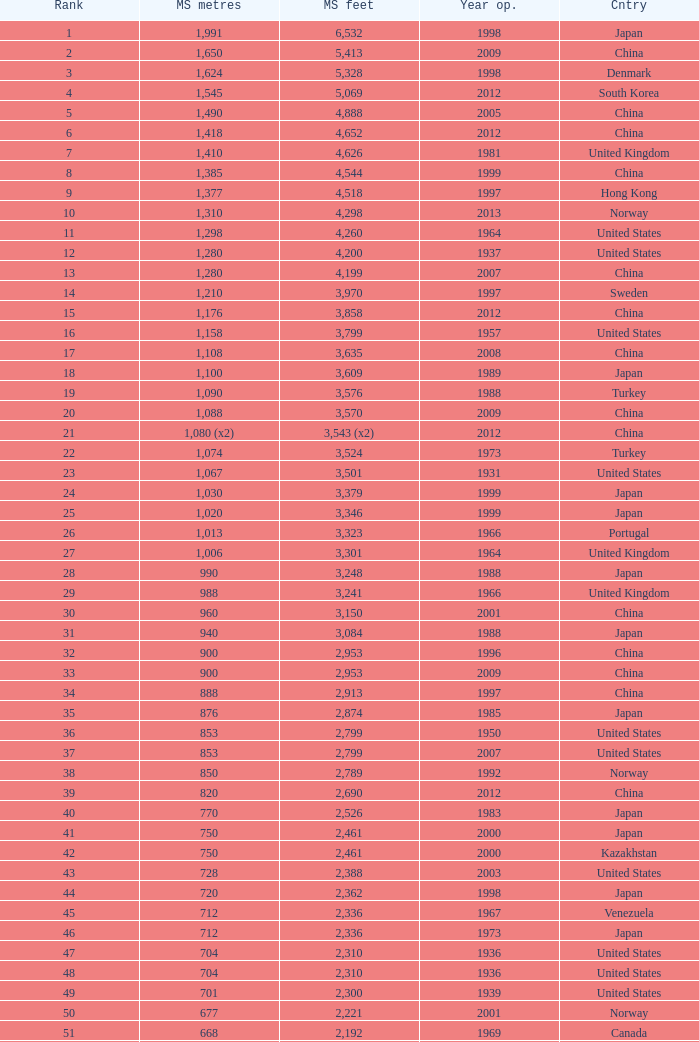What is the maximum ranking from the year beyond 2010 with 430 principal span metres? 94.0. 